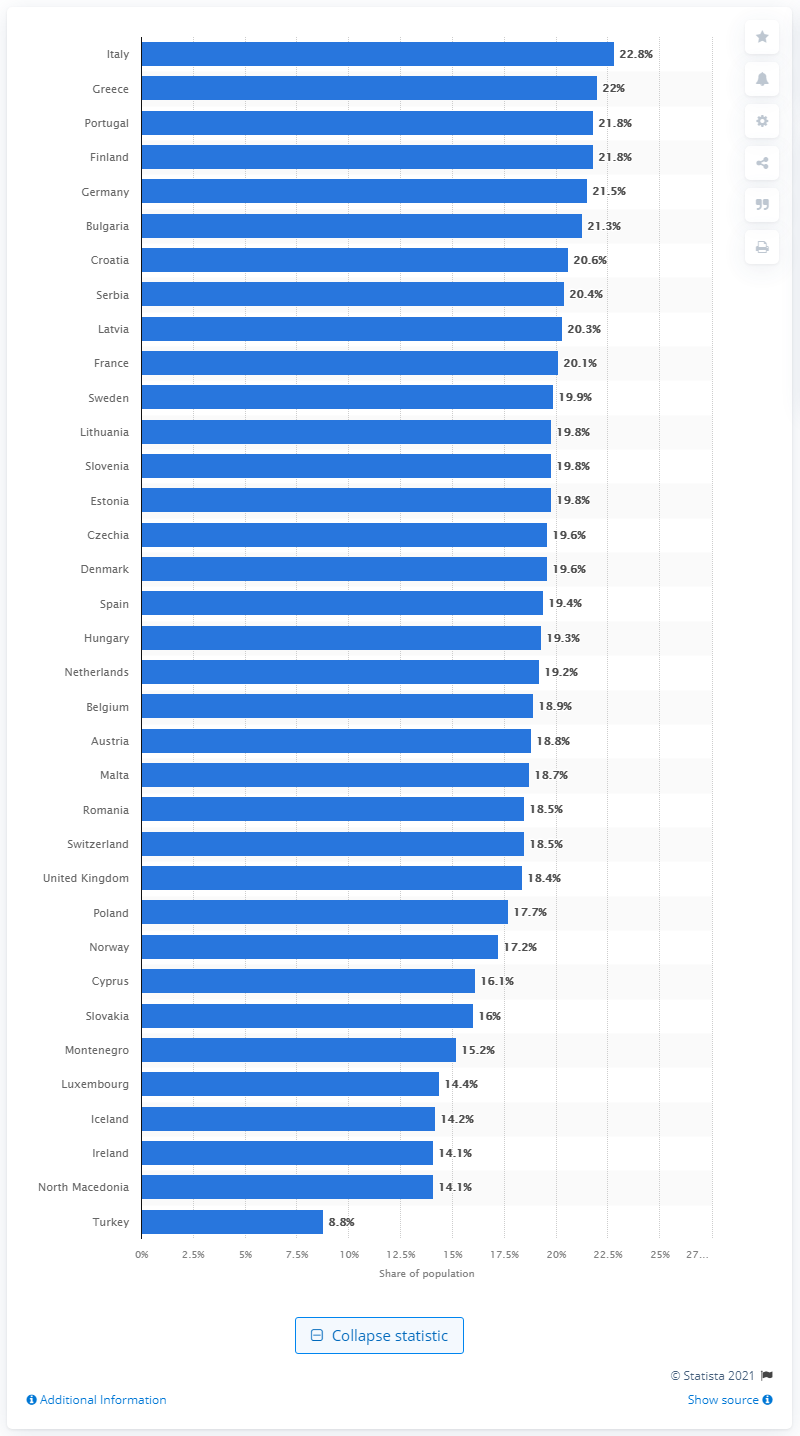Highlight a few significant elements in this photo. Italy had the largest elderly population among all European countries in 2019. 